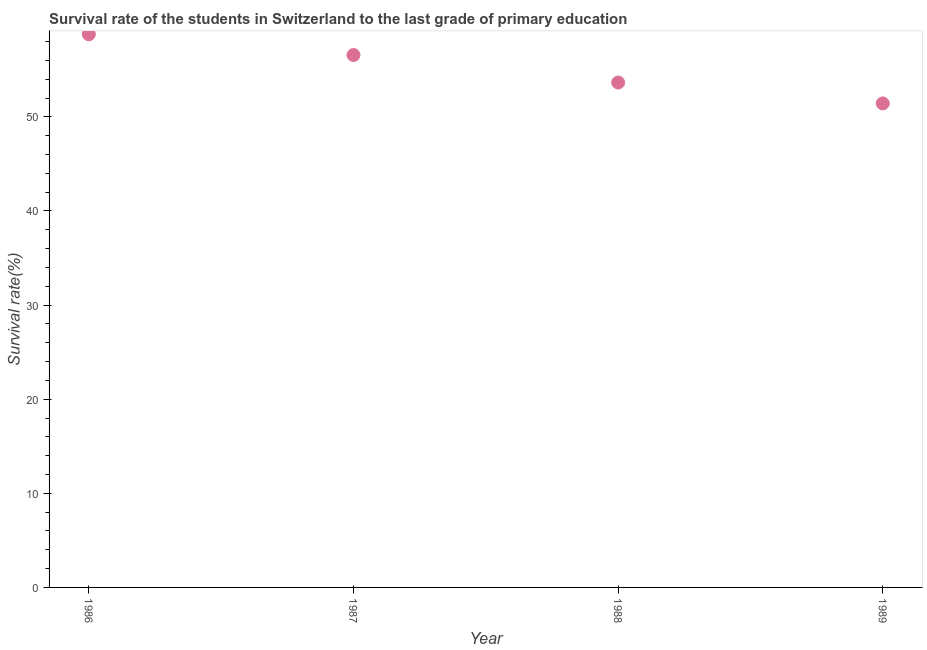What is the survival rate in primary education in 1987?
Make the answer very short. 56.57. Across all years, what is the maximum survival rate in primary education?
Offer a terse response. 58.77. Across all years, what is the minimum survival rate in primary education?
Provide a succinct answer. 51.42. What is the sum of the survival rate in primary education?
Make the answer very short. 220.41. What is the difference between the survival rate in primary education in 1986 and 1987?
Keep it short and to the point. 2.2. What is the average survival rate in primary education per year?
Your response must be concise. 55.1. What is the median survival rate in primary education?
Provide a short and direct response. 55.11. In how many years, is the survival rate in primary education greater than 16 %?
Offer a very short reply. 4. Do a majority of the years between 1986 and 1988 (inclusive) have survival rate in primary education greater than 10 %?
Give a very brief answer. Yes. What is the ratio of the survival rate in primary education in 1987 to that in 1988?
Provide a short and direct response. 1.05. Is the survival rate in primary education in 1987 less than that in 1988?
Keep it short and to the point. No. What is the difference between the highest and the second highest survival rate in primary education?
Offer a very short reply. 2.2. What is the difference between the highest and the lowest survival rate in primary education?
Keep it short and to the point. 7.35. In how many years, is the survival rate in primary education greater than the average survival rate in primary education taken over all years?
Offer a terse response. 2. Does the survival rate in primary education monotonically increase over the years?
Your answer should be compact. No. How many years are there in the graph?
Your response must be concise. 4. Are the values on the major ticks of Y-axis written in scientific E-notation?
Keep it short and to the point. No. Does the graph contain grids?
Give a very brief answer. No. What is the title of the graph?
Offer a very short reply. Survival rate of the students in Switzerland to the last grade of primary education. What is the label or title of the X-axis?
Keep it short and to the point. Year. What is the label or title of the Y-axis?
Make the answer very short. Survival rate(%). What is the Survival rate(%) in 1986?
Make the answer very short. 58.77. What is the Survival rate(%) in 1987?
Make the answer very short. 56.57. What is the Survival rate(%) in 1988?
Provide a short and direct response. 53.65. What is the Survival rate(%) in 1989?
Make the answer very short. 51.42. What is the difference between the Survival rate(%) in 1986 and 1987?
Offer a very short reply. 2.2. What is the difference between the Survival rate(%) in 1986 and 1988?
Keep it short and to the point. 5.13. What is the difference between the Survival rate(%) in 1986 and 1989?
Your response must be concise. 7.35. What is the difference between the Survival rate(%) in 1987 and 1988?
Your answer should be very brief. 2.92. What is the difference between the Survival rate(%) in 1987 and 1989?
Keep it short and to the point. 5.14. What is the difference between the Survival rate(%) in 1988 and 1989?
Your response must be concise. 2.22. What is the ratio of the Survival rate(%) in 1986 to that in 1987?
Offer a very short reply. 1.04. What is the ratio of the Survival rate(%) in 1986 to that in 1988?
Ensure brevity in your answer.  1.1. What is the ratio of the Survival rate(%) in 1986 to that in 1989?
Your answer should be very brief. 1.14. What is the ratio of the Survival rate(%) in 1987 to that in 1988?
Your answer should be compact. 1.05. What is the ratio of the Survival rate(%) in 1988 to that in 1989?
Give a very brief answer. 1.04. 